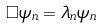Convert formula to latex. <formula><loc_0><loc_0><loc_500><loc_500>\Box \psi _ { n } = \lambda _ { n } \psi _ { n }</formula> 